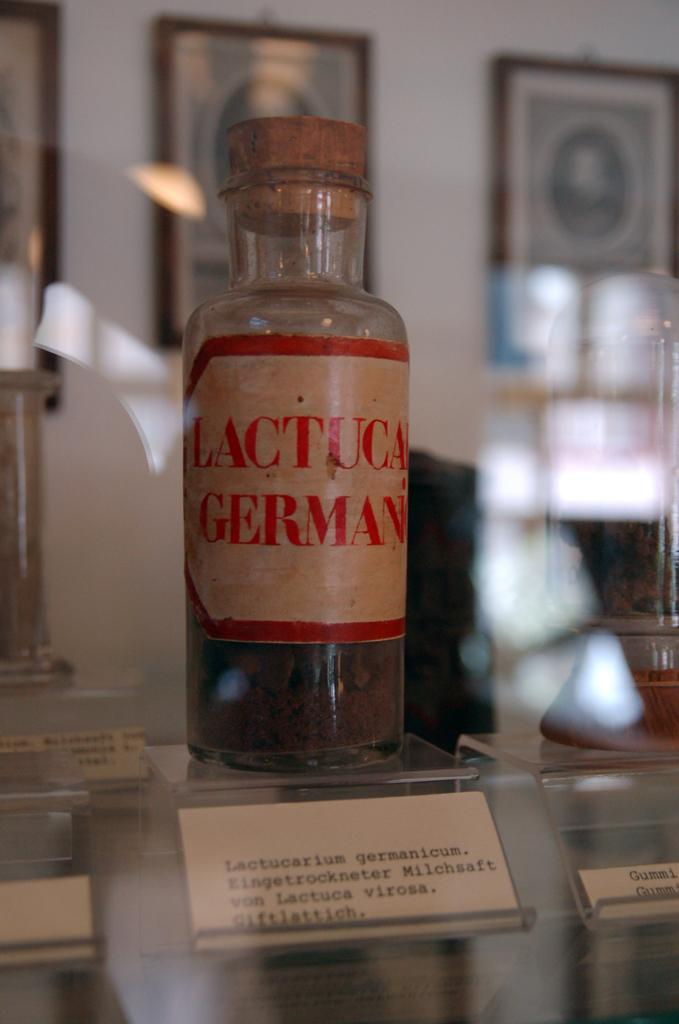<image>
Share a concise interpretation of the image provided. A bottle labelled Lactucarium Germanicum sits on display with some other things. 